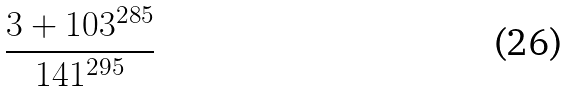<formula> <loc_0><loc_0><loc_500><loc_500>\frac { 3 + 1 0 3 ^ { 2 8 5 } } { 1 4 1 ^ { 2 9 5 } }</formula> 